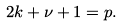Convert formula to latex. <formula><loc_0><loc_0><loc_500><loc_500>2 k + \nu + 1 = p .</formula> 